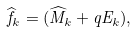<formula> <loc_0><loc_0><loc_500><loc_500>\widehat { f } _ { k } = ( \widehat { M } _ { k } + q E _ { k } ) ,</formula> 